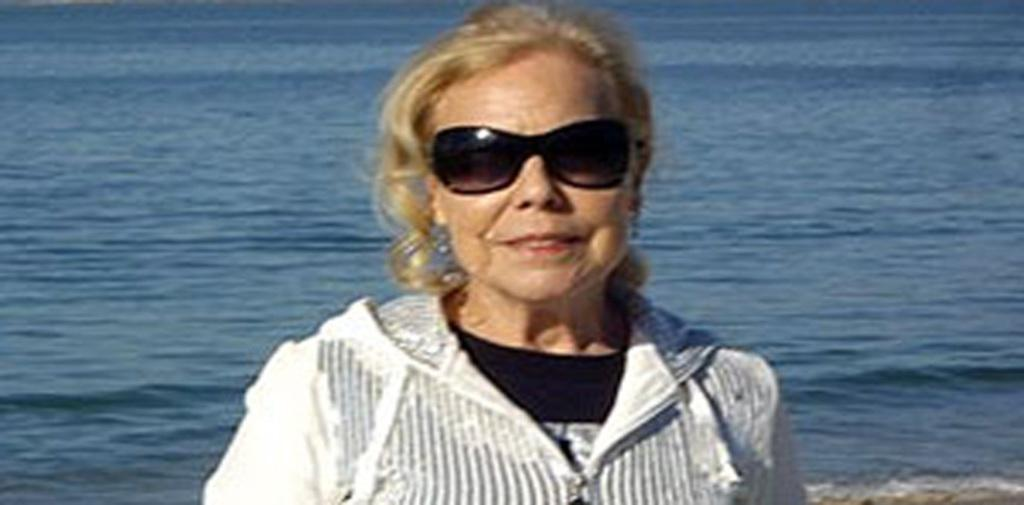What is the main subject of the image? There is a woman in the image. What is the woman wearing on her upper body? The woman is wearing a white jacket and a black T-shirt. Are there any accessories visible on the woman? Yes, the woman is wearing glasses. Where is the woman positioned in the image? The woman is in the center of the image. What can be seen in the background of the image? There is water visible in the background of the image. What type of lace is used to decorate the woman's partner's clothing in the image? There is no partner present in the image, and therefore no clothing or lace can be observed. 